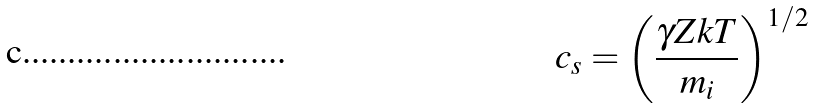Convert formula to latex. <formula><loc_0><loc_0><loc_500><loc_500>c _ { s } = \left ( \frac { \gamma Z k T } { m _ { i } } \right ) ^ { 1 / 2 }</formula> 